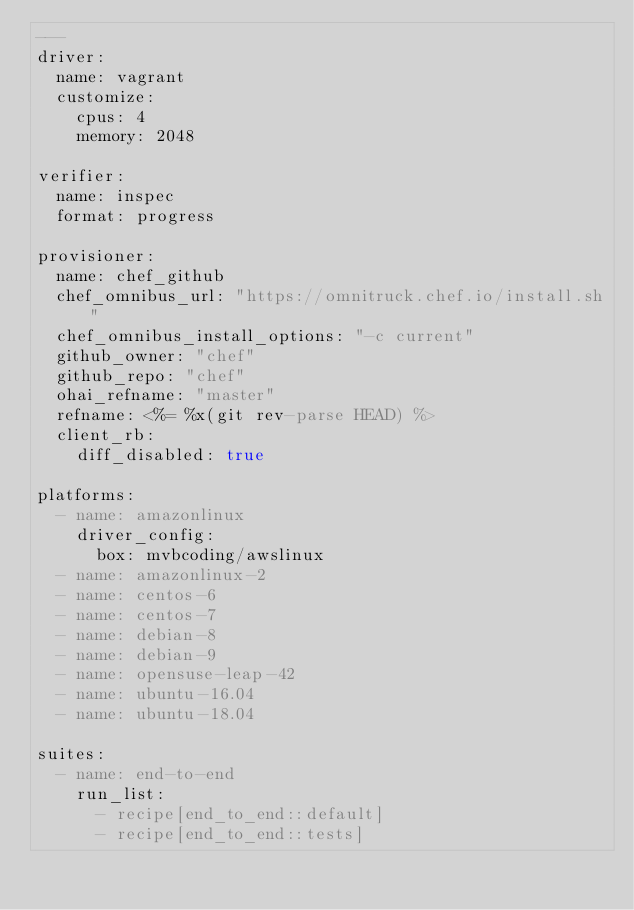<code> <loc_0><loc_0><loc_500><loc_500><_YAML_>---
driver:
  name: vagrant
  customize:
    cpus: 4
    memory: 2048

verifier:
  name: inspec
  format: progress

provisioner:
  name: chef_github
  chef_omnibus_url: "https://omnitruck.chef.io/install.sh"
  chef_omnibus_install_options: "-c current"
  github_owner: "chef"
  github_repo: "chef"
  ohai_refname: "master"
  refname: <%= %x(git rev-parse HEAD) %>
  client_rb:
    diff_disabled: true

platforms:
  - name: amazonlinux
    driver_config:
      box: mvbcoding/awslinux
  - name: amazonlinux-2
  - name: centos-6
  - name: centos-7
  - name: debian-8
  - name: debian-9
  - name: opensuse-leap-42
  - name: ubuntu-16.04
  - name: ubuntu-18.04

suites:
  - name: end-to-end
    run_list:
      - recipe[end_to_end::default]
      - recipe[end_to_end::tests]
</code> 